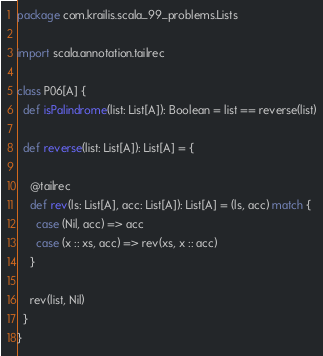Convert code to text. <code><loc_0><loc_0><loc_500><loc_500><_Scala_>package com.krailis.scala_99_problems.Lists

import scala.annotation.tailrec

class P06[A] {
  def isPalindrome(list: List[A]): Boolean = list == reverse(list)

  def reverse(list: List[A]): List[A] = {

    @tailrec
    def rev(ls: List[A], acc: List[A]): List[A] = (ls, acc) match {
      case (Nil, acc) => acc
      case (x :: xs, acc) => rev(xs, x :: acc)
    }

    rev(list, Nil)
  }
}
</code> 